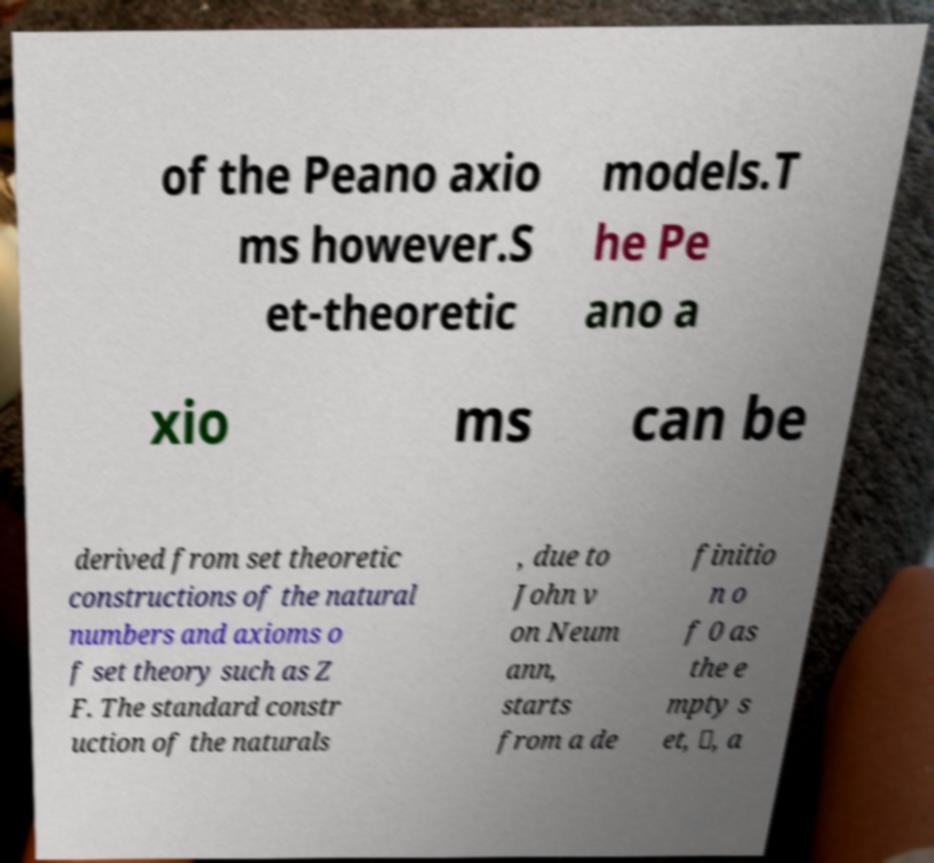For documentation purposes, I need the text within this image transcribed. Could you provide that? of the Peano axio ms however.S et-theoretic models.T he Pe ano a xio ms can be derived from set theoretic constructions of the natural numbers and axioms o f set theory such as Z F. The standard constr uction of the naturals , due to John v on Neum ann, starts from a de finitio n o f 0 as the e mpty s et, ∅, a 